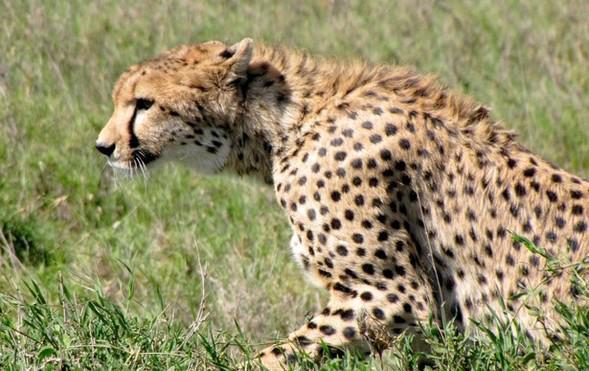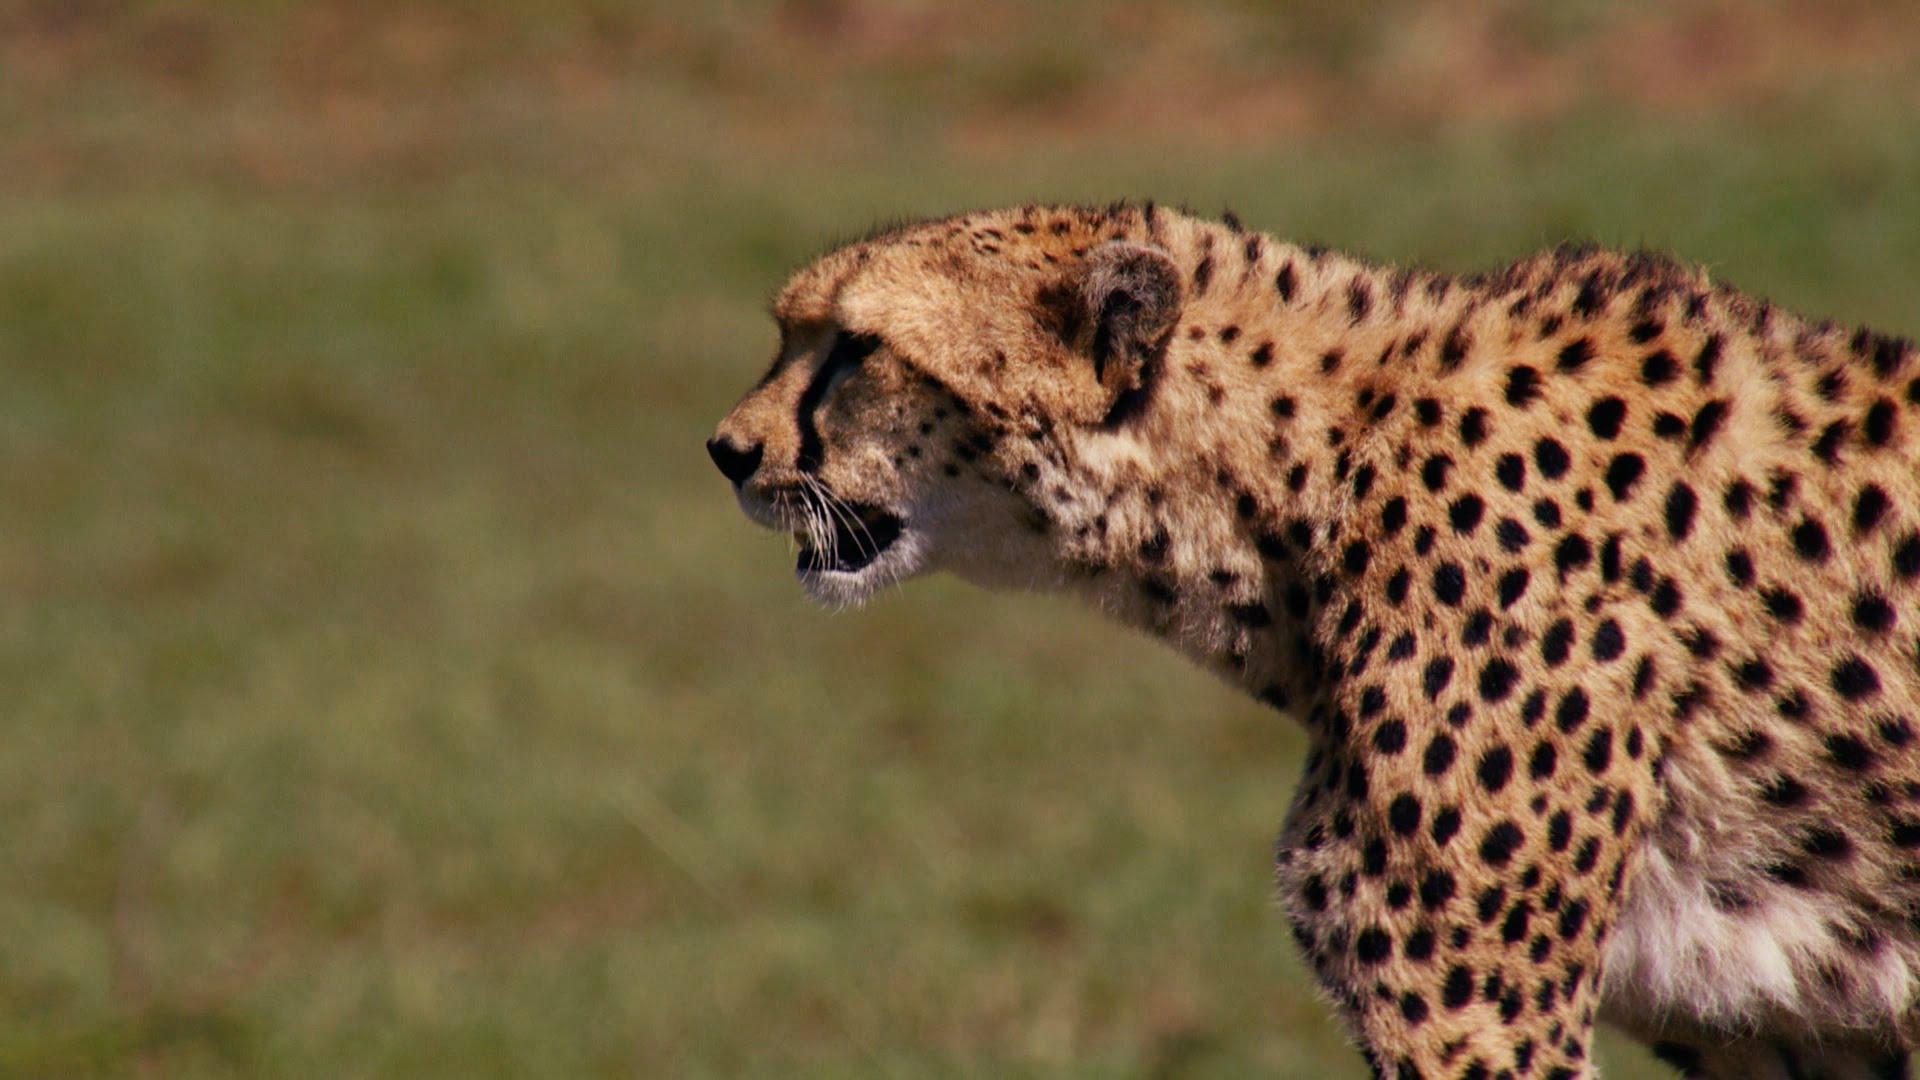The first image is the image on the left, the second image is the image on the right. Assess this claim about the two images: "An image shows two same-sized similarly-posed spotted cats with their heads close together.". Correct or not? Answer yes or no. No. The first image is the image on the left, the second image is the image on the right. Considering the images on both sides, is "The left image contains at least two cheetahs." valid? Answer yes or no. No. 